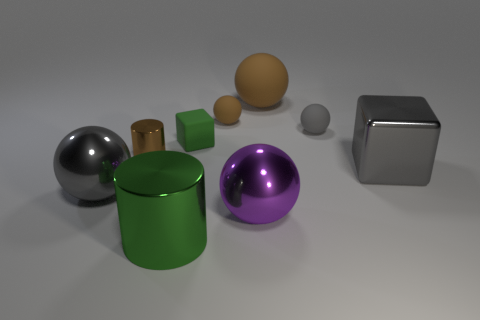There is a gray shiny thing that is on the left side of the gray ball that is behind the large gray metal cube; what is its size?
Keep it short and to the point. Large. Is the number of gray metallic things behind the small cylinder the same as the number of gray rubber balls that are in front of the large cube?
Keep it short and to the point. Yes. Are there any other things that are the same size as the brown shiny cylinder?
Offer a very short reply. Yes. The large sphere that is the same material as the tiny green cube is what color?
Provide a short and direct response. Brown. Are the large brown object and the gray sphere that is left of the large green thing made of the same material?
Provide a succinct answer. No. What is the color of the object that is both on the left side of the green block and behind the metal cube?
Make the answer very short. Brown. What number of cubes are either big gray shiny objects or gray matte things?
Your response must be concise. 1. Do the large rubber thing and the green thing that is behind the big gray metallic cube have the same shape?
Your answer should be very brief. No. What size is the ball that is both left of the large purple shiny thing and in front of the brown metal object?
Your answer should be very brief. Large. What shape is the green rubber thing?
Your answer should be very brief. Cube. 